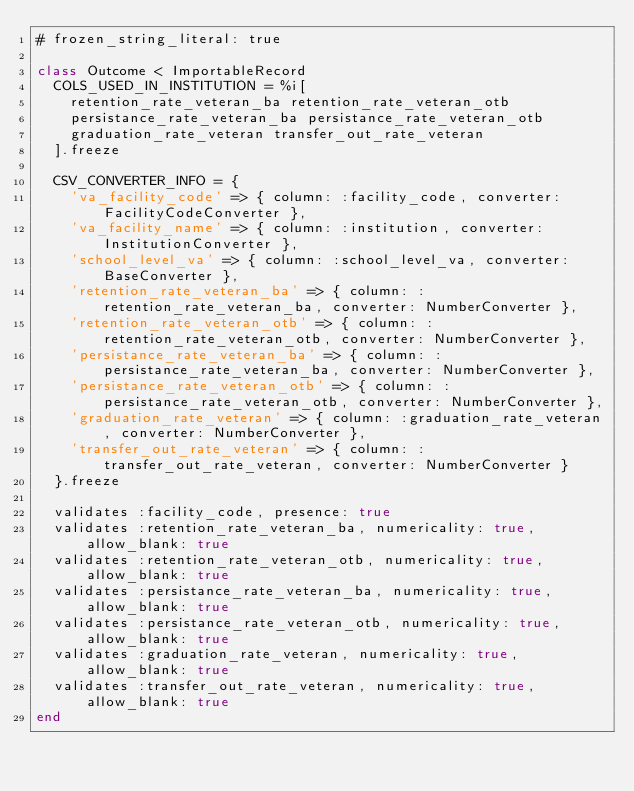<code> <loc_0><loc_0><loc_500><loc_500><_Ruby_># frozen_string_literal: true

class Outcome < ImportableRecord
  COLS_USED_IN_INSTITUTION = %i[
    retention_rate_veteran_ba retention_rate_veteran_otb
    persistance_rate_veteran_ba persistance_rate_veteran_otb
    graduation_rate_veteran transfer_out_rate_veteran
  ].freeze

  CSV_CONVERTER_INFO = {
    'va_facility_code' => { column: :facility_code, converter: FacilityCodeConverter },
    'va_facility_name' => { column: :institution, converter: InstitutionConverter },
    'school_level_va' => { column: :school_level_va, converter: BaseConverter },
    'retention_rate_veteran_ba' => { column: :retention_rate_veteran_ba, converter: NumberConverter },
    'retention_rate_veteran_otb' => { column: :retention_rate_veteran_otb, converter: NumberConverter },
    'persistance_rate_veteran_ba' => { column: :persistance_rate_veteran_ba, converter: NumberConverter },
    'persistance_rate_veteran_otb' => { column: :persistance_rate_veteran_otb, converter: NumberConverter },
    'graduation_rate_veteran' => { column: :graduation_rate_veteran, converter: NumberConverter },
    'transfer_out_rate_veteran' => { column: :transfer_out_rate_veteran, converter: NumberConverter }
  }.freeze

  validates :facility_code, presence: true
  validates :retention_rate_veteran_ba, numericality: true, allow_blank: true
  validates :retention_rate_veteran_otb, numericality: true, allow_blank: true
  validates :persistance_rate_veteran_ba, numericality: true, allow_blank: true
  validates :persistance_rate_veteran_otb, numericality: true, allow_blank: true
  validates :graduation_rate_veteran, numericality: true, allow_blank: true
  validates :transfer_out_rate_veteran, numericality: true, allow_blank: true
end
</code> 